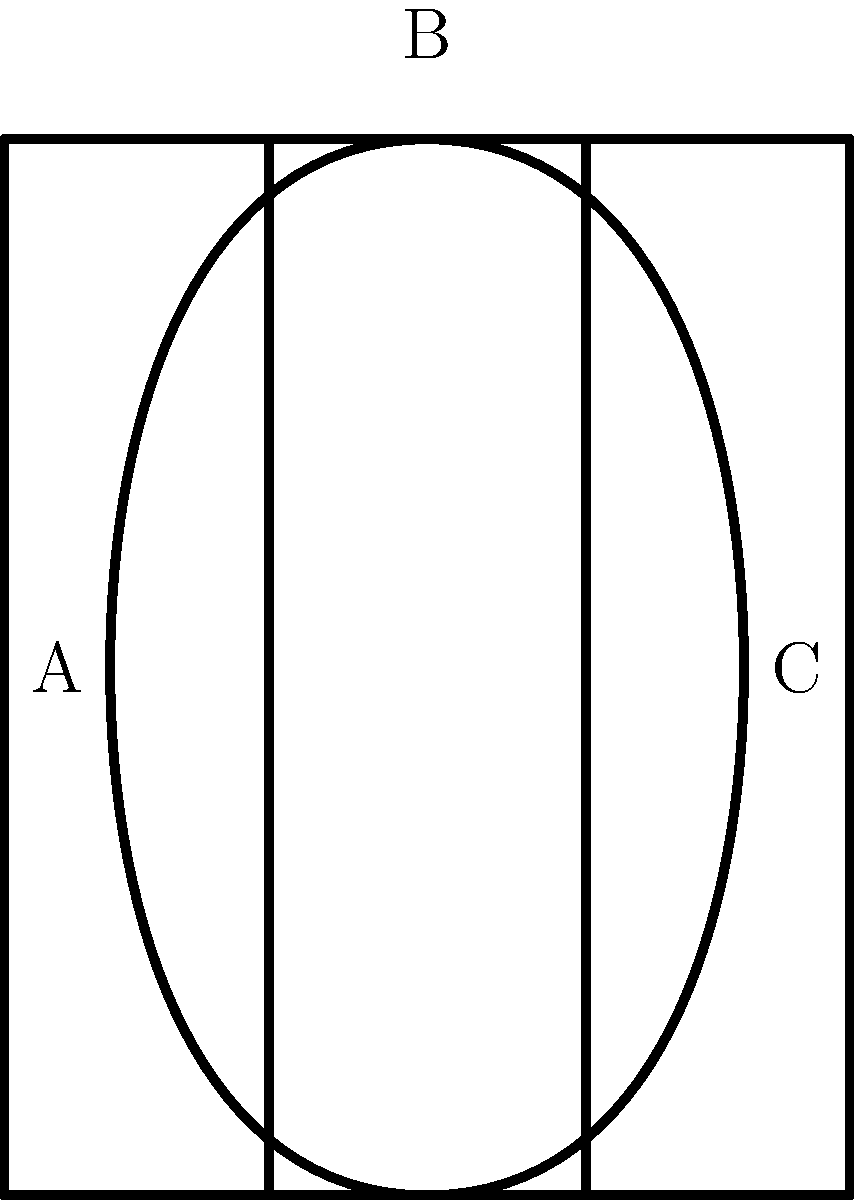In the diagram above, three common clerical vestments are represented by simplified outlines. Which letter corresponds to the chasuble, a sleeveless outer vestment worn by priests during Mass? To identify the chasuble in this diagram, let's examine each outline:

1. Outline A: This is a straight, rectangular shape that extends from top to bottom. This represents the alb, a full-length white garment worn under other vestments.

2. Outline B: This is a narrow, vertical strip that splits into two at the bottom. This represents the stole, a long narrow strip of cloth worn around the neck.

3. Outline C: This outline has a distinctive shape that is wide at the bottom, narrows at the shoulders, and then widens again at the top. This bell-like or shield-like shape is characteristic of the chasuble.

The chasuble is the outermost liturgical vestment worn by priests for the celebration of the Mass. Its shape evolved from a circular cloak, and modern chasubles often retain this circular or shield-like appearance when viewed from the front or back.

Therefore, the letter corresponding to the chasuble is C.
Answer: C 